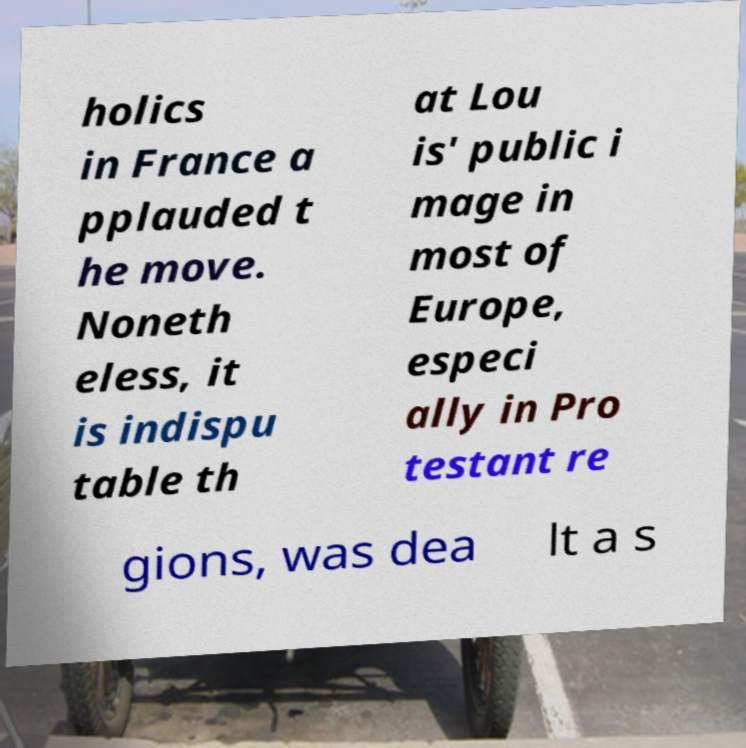Can you read and provide the text displayed in the image?This photo seems to have some interesting text. Can you extract and type it out for me? holics in France a pplauded t he move. Noneth eless, it is indispu table th at Lou is' public i mage in most of Europe, especi ally in Pro testant re gions, was dea lt a s 